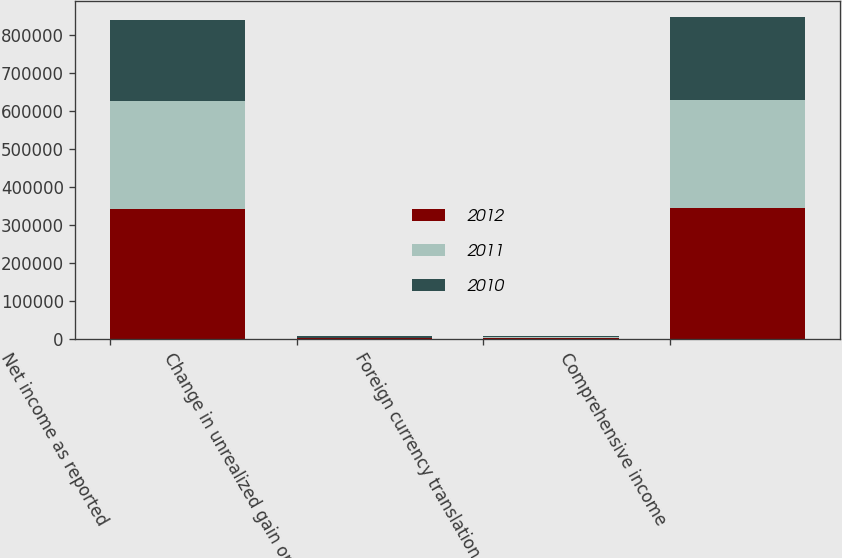Convert chart. <chart><loc_0><loc_0><loc_500><loc_500><stacked_bar_chart><ecel><fcel>Net income as reported<fcel>Change in unrealized gain on<fcel>Foreign currency translation<fcel>Comprehensive income<nl><fcel>2012<fcel>340020<fcel>1525<fcel>2096<fcel>343641<nl><fcel>2011<fcel>286219<fcel>1478<fcel>3306<fcel>284391<nl><fcel>2010<fcel>212029<fcel>3111<fcel>1837<fcel>216977<nl></chart> 